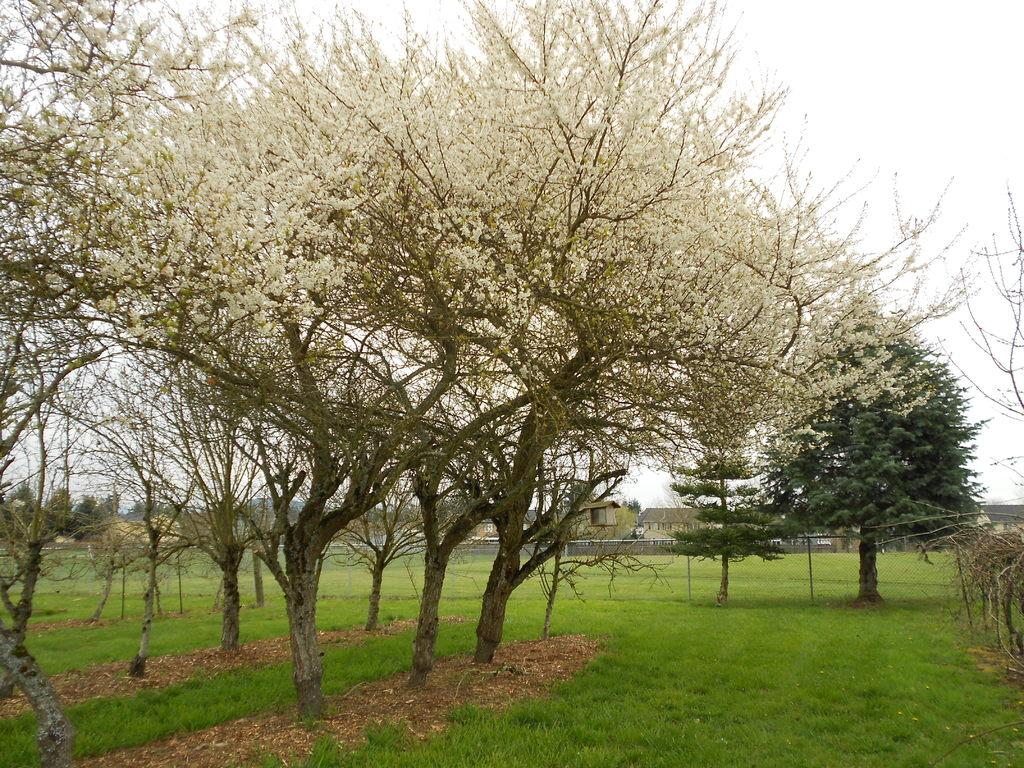What type of trees are in the image? The image contains trees with white flowers. What is at the bottom of the image? There is grass at the bottom of the image. What can be seen in the background of the image? There are houses in the background of the image. What is visible at the top of the image? The sky is visible at the top of the image. What type of authority is depicted in the image? There is no authority figure present in the image; it features trees with white flowers, grass, houses, and the sky. What discovery was made by the snake in the image? There is no snake present in the image, so no discovery can be attributed to it. 